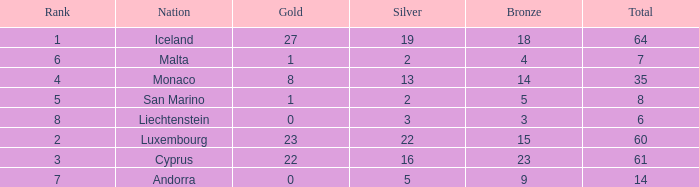Where does Iceland rank with under 19 silvers? None. 